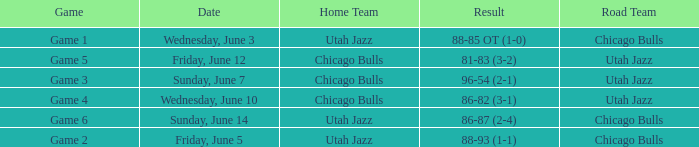Game of game 5 had what result? 81-83 (3-2). I'm looking to parse the entire table for insights. Could you assist me with that? {'header': ['Game', 'Date', 'Home Team', 'Result', 'Road Team'], 'rows': [['Game 1', 'Wednesday, June 3', 'Utah Jazz', '88-85 OT (1-0)', 'Chicago Bulls'], ['Game 5', 'Friday, June 12', 'Chicago Bulls', '81-83 (3-2)', 'Utah Jazz'], ['Game 3', 'Sunday, June 7', 'Chicago Bulls', '96-54 (2-1)', 'Utah Jazz'], ['Game 4', 'Wednesday, June 10', 'Chicago Bulls', '86-82 (3-1)', 'Utah Jazz'], ['Game 6', 'Sunday, June 14', 'Utah Jazz', '86-87 (2-4)', 'Chicago Bulls'], ['Game 2', 'Friday, June 5', 'Utah Jazz', '88-93 (1-1)', 'Chicago Bulls']]} 